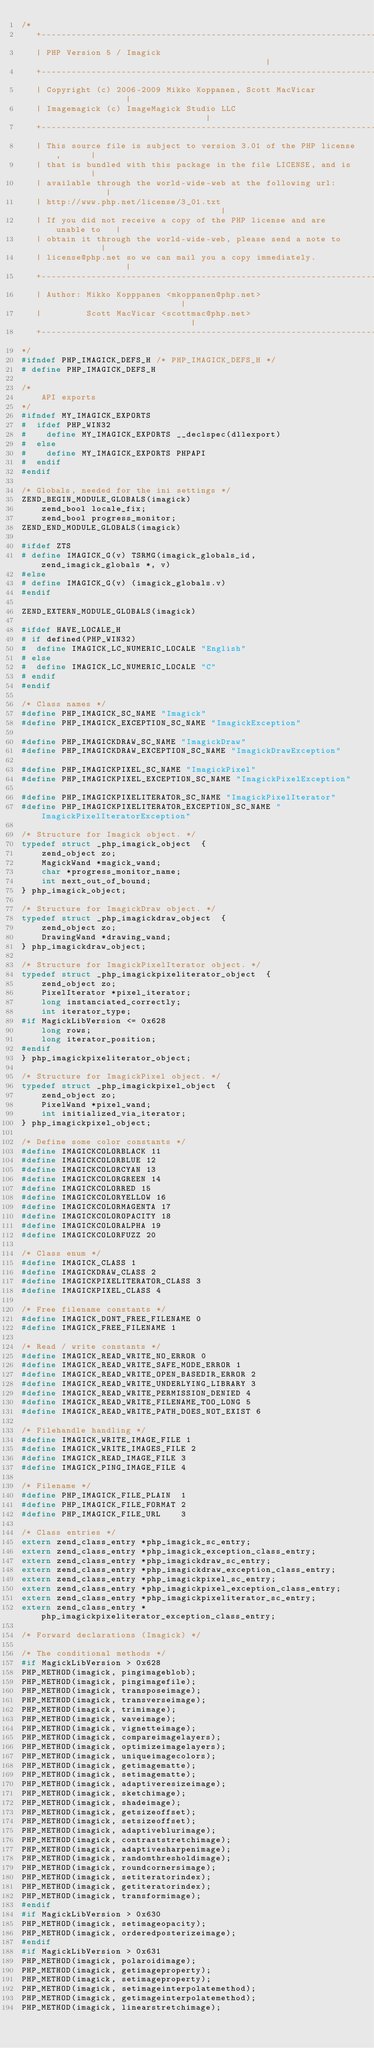<code> <loc_0><loc_0><loc_500><loc_500><_C_>/*
   +----------------------------------------------------------------------+
   | PHP Version 5 / Imagick	                                          |
   +----------------------------------------------------------------------+
   | Copyright (c) 2006-2009 Mikko Koppanen, Scott MacVicar               |
   | Imagemagick (c) ImageMagick Studio LLC                               |
   +----------------------------------------------------------------------+
   | This source file is subject to version 3.01 of the PHP license,      |
   | that is bundled with this package in the file LICENSE, and is        |
   | available through the world-wide-web at the following url:           |
   | http://www.php.net/license/3_01.txt                                  |
   | If you did not receive a copy of the PHP license and are unable to   |
   | obtain it through the world-wide-web, please send a note to          |
   | license@php.net so we can mail you a copy immediately.               |
   +----------------------------------------------------------------------+
   | Author: Mikko Kopppanen <mkoppanen@php.net>                          |
   |         Scott MacVicar <scottmac@php.net>                            |
   +----------------------------------------------------------------------+
*/
#ifndef PHP_IMAGICK_DEFS_H /* PHP_IMAGICK_DEFS_H */
# define PHP_IMAGICK_DEFS_H

/*
	API exports
*/
#ifndef MY_IMAGICK_EXPORTS
#  ifdef PHP_WIN32
#    define MY_IMAGICK_EXPORTS __declspec(dllexport)
#  else
#    define MY_IMAGICK_EXPORTS PHPAPI
#  endif
#endif

/* Globals, needed for the ini settings */
ZEND_BEGIN_MODULE_GLOBALS(imagick)
	zend_bool locale_fix;
	zend_bool progress_monitor;
ZEND_END_MODULE_GLOBALS(imagick)

#ifdef ZTS
# define IMAGICK_G(v) TSRMG(imagick_globals_id, zend_imagick_globals *, v)
#else
# define IMAGICK_G(v) (imagick_globals.v)
#endif

ZEND_EXTERN_MODULE_GLOBALS(imagick)

#ifdef HAVE_LOCALE_H
# if defined(PHP_WIN32)
#  define IMAGICK_LC_NUMERIC_LOCALE "English"
# else
#  define IMAGICK_LC_NUMERIC_LOCALE "C"
# endif
#endif

/* Class names */
#define PHP_IMAGICK_SC_NAME "Imagick"
#define PHP_IMAGICK_EXCEPTION_SC_NAME "ImagickException"

#define PHP_IMAGICKDRAW_SC_NAME "ImagickDraw"
#define PHP_IMAGICKDRAW_EXCEPTION_SC_NAME "ImagickDrawException"

#define PHP_IMAGICKPIXEL_SC_NAME "ImagickPixel"
#define PHP_IMAGICKPIXEL_EXCEPTION_SC_NAME "ImagickPixelException"

#define PHP_IMAGICKPIXELITERATOR_SC_NAME "ImagickPixelIterator"
#define PHP_IMAGICKPIXELITERATOR_EXCEPTION_SC_NAME "ImagickPixelIteratorException"

/* Structure for Imagick object. */
typedef struct _php_imagick_object  {
	zend_object zo;
	MagickWand *magick_wand;
	char *progress_monitor_name;
	int next_out_of_bound;
} php_imagick_object;

/* Structure for ImagickDraw object. */
typedef struct _php_imagickdraw_object  {
	zend_object zo;
	DrawingWand *drawing_wand;
} php_imagickdraw_object;

/* Structure for ImagickPixelIterator object. */
typedef struct _php_imagickpixeliterator_object  {
	zend_object zo;
	PixelIterator *pixel_iterator;
	long instanciated_correctly;
	int iterator_type;
#if MagickLibVersion <= 0x628
	long rows;
	long iterator_position;
#endif
} php_imagickpixeliterator_object;

/* Structure for ImagickPixel object. */
typedef struct _php_imagickpixel_object  {
    zend_object zo;
    PixelWand *pixel_wand;
	int initialized_via_iterator;
} php_imagickpixel_object;

/* Define some color constants */
#define IMAGICKCOLORBLACK 11
#define IMAGICKCOLORBLUE 12
#define IMAGICKCOLORCYAN 13
#define IMAGICKCOLORGREEN 14
#define IMAGICKCOLORRED 15
#define IMAGICKCOLORYELLOW 16
#define IMAGICKCOLORMAGENTA 17
#define IMAGICKCOLOROPACITY 18
#define IMAGICKCOLORALPHA 19
#define IMAGICKCOLORFUZZ 20

/* Class enum */
#define IMAGICK_CLASS 1
#define IMAGICKDRAW_CLASS 2
#define IMAGICKPIXELITERATOR_CLASS 3
#define IMAGICKPIXEL_CLASS 4

/* Free filename constants */
#define IMAGICK_DONT_FREE_FILENAME 0
#define IMAGICK_FREE_FILENAME 1

/* Read / write constants */
#define IMAGICK_READ_WRITE_NO_ERROR 0
#define IMAGICK_READ_WRITE_SAFE_MODE_ERROR 1
#define IMAGICK_READ_WRITE_OPEN_BASEDIR_ERROR 2
#define IMAGICK_READ_WRITE_UNDERLYING_LIBRARY 3
#define IMAGICK_READ_WRITE_PERMISSION_DENIED 4
#define IMAGICK_READ_WRITE_FILENAME_TOO_LONG 5
#define IMAGICK_READ_WRITE_PATH_DOES_NOT_EXIST 6

/* Filehandle handling */
#define IMAGICK_WRITE_IMAGE_FILE 1
#define IMAGICK_WRITE_IMAGES_FILE 2
#define IMAGICK_READ_IMAGE_FILE 3
#define IMAGICK_PING_IMAGE_FILE 4

/* Filename */
#define PHP_IMAGICK_FILE_PLAIN	1
#define PHP_IMAGICK_FILE_FORMAT	2
#define PHP_IMAGICK_FILE_URL	3

/* Class entries */
extern zend_class_entry *php_imagick_sc_entry;
extern zend_class_entry *php_imagick_exception_class_entry;
extern zend_class_entry *php_imagickdraw_sc_entry;
extern zend_class_entry *php_imagickdraw_exception_class_entry;
extern zend_class_entry *php_imagickpixel_sc_entry;
extern zend_class_entry *php_imagickpixel_exception_class_entry;
extern zend_class_entry *php_imagickpixeliterator_sc_entry;
extern zend_class_entry *php_imagickpixeliterator_exception_class_entry;

/* Forward declarations (Imagick) */

/* The conditional methods */
#if MagickLibVersion > 0x628
PHP_METHOD(imagick, pingimageblob);
PHP_METHOD(imagick, pingimagefile);
PHP_METHOD(imagick, transposeimage);
PHP_METHOD(imagick, transverseimage);
PHP_METHOD(imagick, trimimage);
PHP_METHOD(imagick, waveimage);
PHP_METHOD(imagick, vignetteimage);
PHP_METHOD(imagick, compareimagelayers);
PHP_METHOD(imagick, optimizeimagelayers);
PHP_METHOD(imagick, uniqueimagecolors);
PHP_METHOD(imagick, getimagematte);
PHP_METHOD(imagick, setimagematte);
PHP_METHOD(imagick, adaptiveresizeimage);
PHP_METHOD(imagick, sketchimage);
PHP_METHOD(imagick, shadeimage);
PHP_METHOD(imagick, getsizeoffset);
PHP_METHOD(imagick, setsizeoffset);
PHP_METHOD(imagick, adaptiveblurimage);
PHP_METHOD(imagick, contraststretchimage);
PHP_METHOD(imagick, adaptivesharpenimage);
PHP_METHOD(imagick, randomthresholdimage);
PHP_METHOD(imagick, roundcornersimage);
PHP_METHOD(imagick, setiteratorindex);
PHP_METHOD(imagick, getiteratorindex);
PHP_METHOD(imagick, transformimage);
#endif
#if MagickLibVersion > 0x630
PHP_METHOD(imagick, setimageopacity);
PHP_METHOD(imagick, orderedposterizeimage);
#endif
#if MagickLibVersion > 0x631
PHP_METHOD(imagick, polaroidimage);
PHP_METHOD(imagick, getimageproperty);
PHP_METHOD(imagick, setimageproperty);
PHP_METHOD(imagick, setimageinterpolatemethod);
PHP_METHOD(imagick, getimageinterpolatemethod);
PHP_METHOD(imagick, linearstretchimage);</code> 